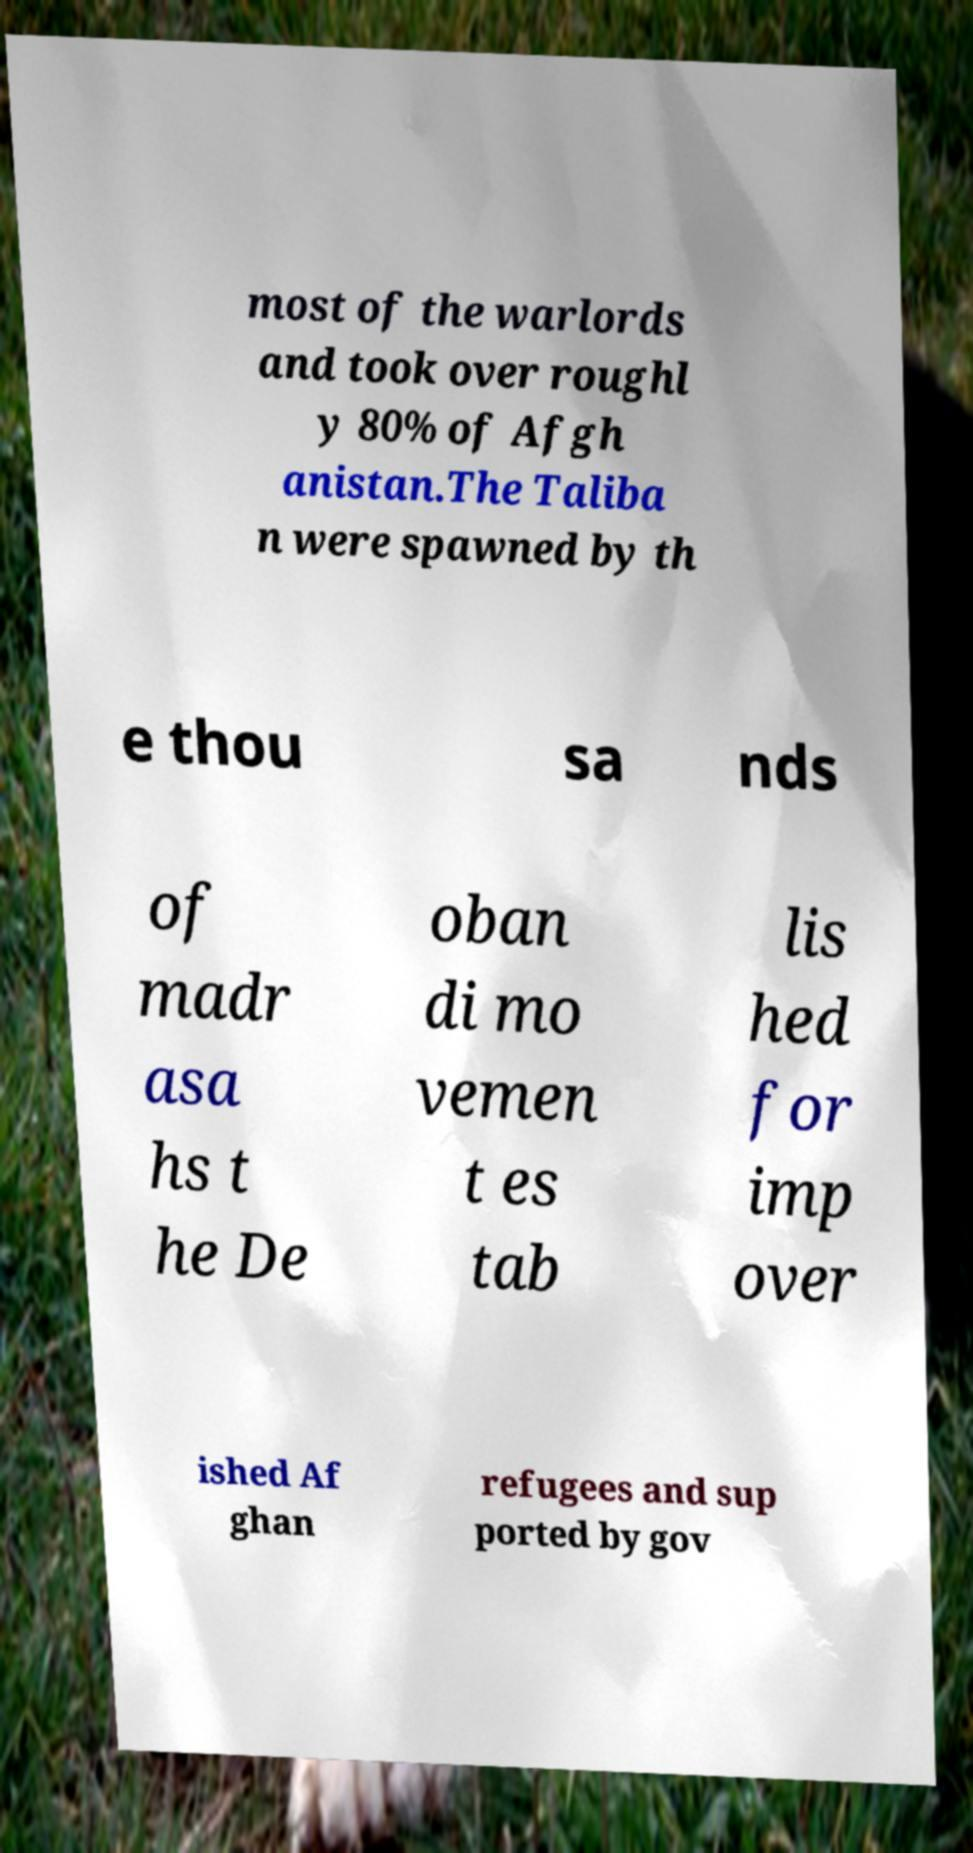Could you assist in decoding the text presented in this image and type it out clearly? most of the warlords and took over roughl y 80% of Afgh anistan.The Taliba n were spawned by th e thou sa nds of madr asa hs t he De oban di mo vemen t es tab lis hed for imp over ished Af ghan refugees and sup ported by gov 